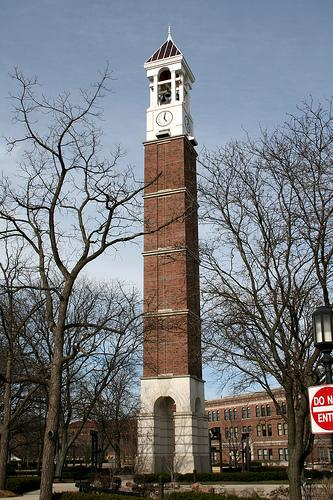Count the number of distinct objects mentioned in the image. There are approximately 13 distinct objects mentioned in the image, including the clock tower, trees, building, do not enter sign, lamp post, benches, walkway, hedges, bells, and arches. Identify any signage present in the image and describe its features. There is a "do not enter" sign in the image, which appears multiple times with varying sizes, ranging from 22 to 33 in width and height. Based on the image, determine the likely purpose of the location. The location is likely an academic or institutional area, as it features a clock tower, a brick building in the background, a walkway with benches, and well-maintained surroundings. What is the focal point of the image and what are its main characteristics? The focal point of the image is a clock tower with a clock on top, surrounded by trees, and made mostly from brick, having a white top, grey bottom, and multicolored brick middle part. Identify if there are any elements within the image that imply movement or activity, and describe them. There is no direct indication of movement or activity in the image, but aspects such as the clock showing a specific time (5:01) and people possibly using the benches and walkway could suggest an element of life and activity in the scene. Describe the surroundings and additional elements within the scene. There are bare trees surrounding the tall clock tower, a long brick building in the background, a lamp post, a do not enter sign, and a walkway with benches lining it. Rate the quality of the image's composition and details. Is it well-composed and visually appealing? The image appears to be well-composed and visually appealing, with a clear focal point, coherent surroundings, and various interesting elements such as the tower's detailed multicolored brickwork. Discuss how objects in the image interact with one another and their environment. The objects in the image create a harmonious scene, with the towering clock tower serving as the focal point, while bare trees surround it and additional elements like the lamp post and signage complement the composition. The walkway with benches and hedges invites people to interact and spend time in the area. How many trees are there in the image and what is the state of their leaves? There are at least two groups of trees in the image, both on the left and right sides of the tower. They are leafless, with some showing scars from former branches. What emotion or feeling can be associated with this image? The image evokes a sense of tranquility, as the bare trees and the serene architecture of the clock tower create a peaceful atmosphere. 